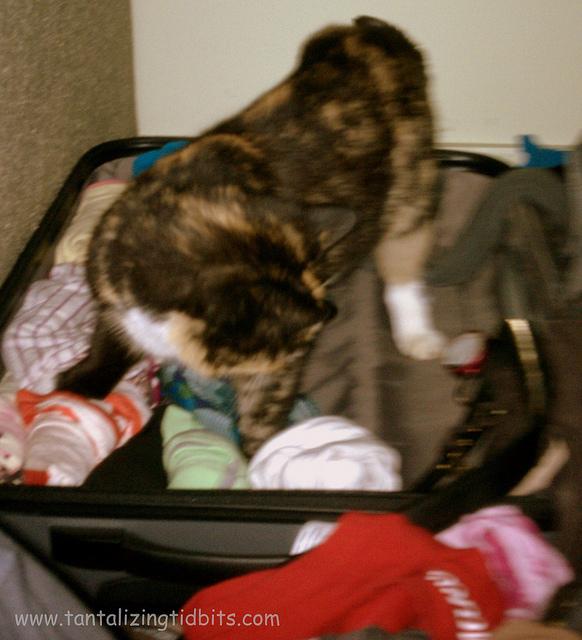Is this cat traveling with his or her owner on the trip?
Quick response, please. No. Is the cat calm?
Quick response, please. No. Is the suitcase packed?
Give a very brief answer. Yes. What kind of cat is this?
Be succinct. Calico. 